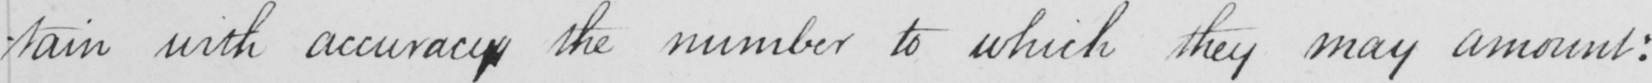Can you tell me what this handwritten text says? -tain with accuracy the number to which they may amount : 